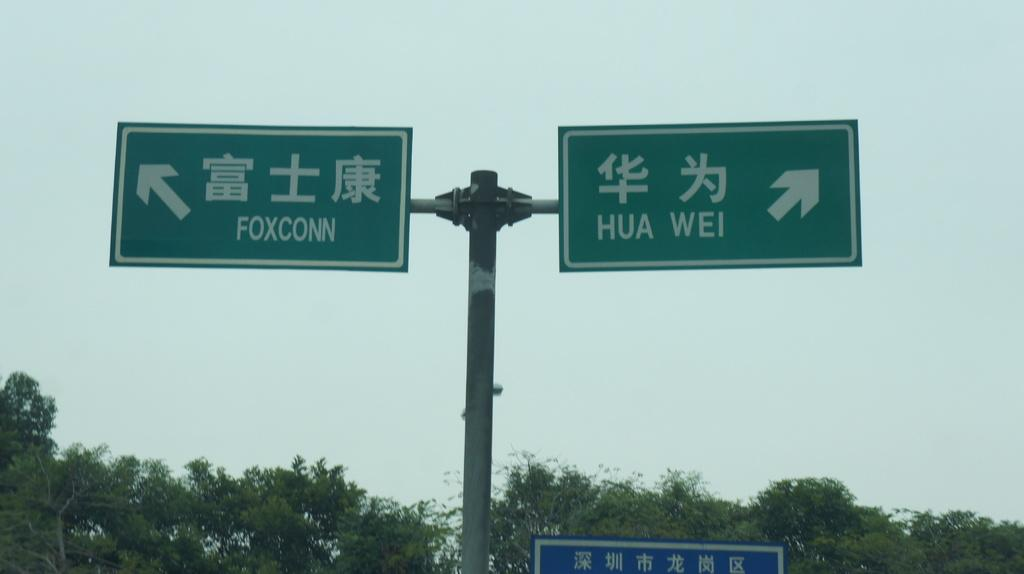Provide a one-sentence caption for the provided image. The road sign indicates that Foxconn is to the left and Hua Wei is to the right. 